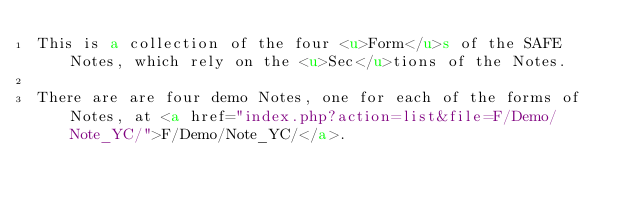Convert code to text. <code><loc_0><loc_0><loc_500><loc_500><_HTML_>This is a collection of the four <u>Form</u>s of the SAFE Notes, which rely on the <u>Sec</u>tions of the Notes.  

There are are four demo Notes, one for each of the forms of Notes, at <a href="index.php?action=list&file=F/Demo/Note_YC/">F/Demo/Note_YC/</a>.
</code> 